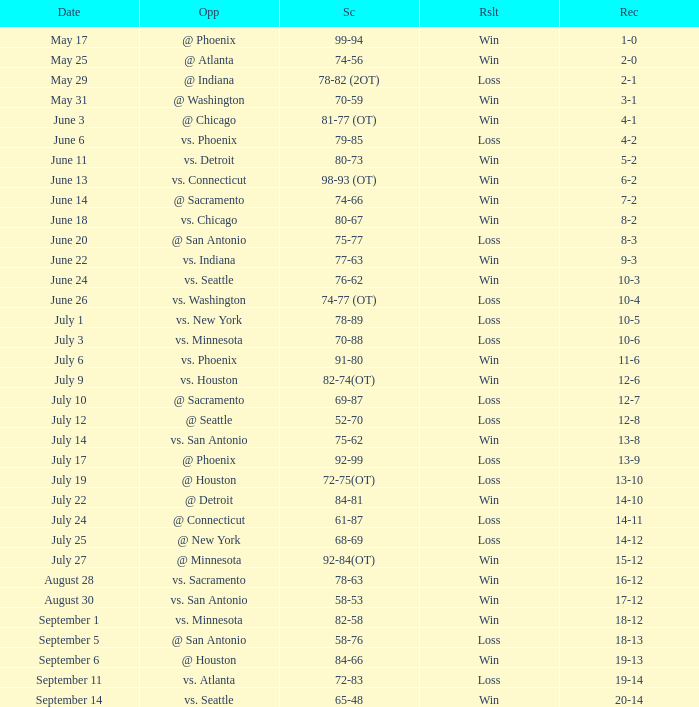What is the Record of the game with a Score of 65-48? 20-14. Give me the full table as a dictionary. {'header': ['Date', 'Opp', 'Sc', 'Rslt', 'Rec'], 'rows': [['May 17', '@ Phoenix', '99-94', 'Win', '1-0'], ['May 25', '@ Atlanta', '74-56', 'Win', '2-0'], ['May 29', '@ Indiana', '78-82 (2OT)', 'Loss', '2-1'], ['May 31', '@ Washington', '70-59', 'Win', '3-1'], ['June 3', '@ Chicago', '81-77 (OT)', 'Win', '4-1'], ['June 6', 'vs. Phoenix', '79-85', 'Loss', '4-2'], ['June 11', 'vs. Detroit', '80-73', 'Win', '5-2'], ['June 13', 'vs. Connecticut', '98-93 (OT)', 'Win', '6-2'], ['June 14', '@ Sacramento', '74-66', 'Win', '7-2'], ['June 18', 'vs. Chicago', '80-67', 'Win', '8-2'], ['June 20', '@ San Antonio', '75-77', 'Loss', '8-3'], ['June 22', 'vs. Indiana', '77-63', 'Win', '9-3'], ['June 24', 'vs. Seattle', '76-62', 'Win', '10-3'], ['June 26', 'vs. Washington', '74-77 (OT)', 'Loss', '10-4'], ['July 1', 'vs. New York', '78-89', 'Loss', '10-5'], ['July 3', 'vs. Minnesota', '70-88', 'Loss', '10-6'], ['July 6', 'vs. Phoenix', '91-80', 'Win', '11-6'], ['July 9', 'vs. Houston', '82-74(OT)', 'Win', '12-6'], ['July 10', '@ Sacramento', '69-87', 'Loss', '12-7'], ['July 12', '@ Seattle', '52-70', 'Loss', '12-8'], ['July 14', 'vs. San Antonio', '75-62', 'Win', '13-8'], ['July 17', '@ Phoenix', '92-99', 'Loss', '13-9'], ['July 19', '@ Houston', '72-75(OT)', 'Loss', '13-10'], ['July 22', '@ Detroit', '84-81', 'Win', '14-10'], ['July 24', '@ Connecticut', '61-87', 'Loss', '14-11'], ['July 25', '@ New York', '68-69', 'Loss', '14-12'], ['July 27', '@ Minnesota', '92-84(OT)', 'Win', '15-12'], ['August 28', 'vs. Sacramento', '78-63', 'Win', '16-12'], ['August 30', 'vs. San Antonio', '58-53', 'Win', '17-12'], ['September 1', 'vs. Minnesota', '82-58', 'Win', '18-12'], ['September 5', '@ San Antonio', '58-76', 'Loss', '18-13'], ['September 6', '@ Houston', '84-66', 'Win', '19-13'], ['September 11', 'vs. Atlanta', '72-83', 'Loss', '19-14'], ['September 14', 'vs. Seattle', '65-48', 'Win', '20-14']]} 